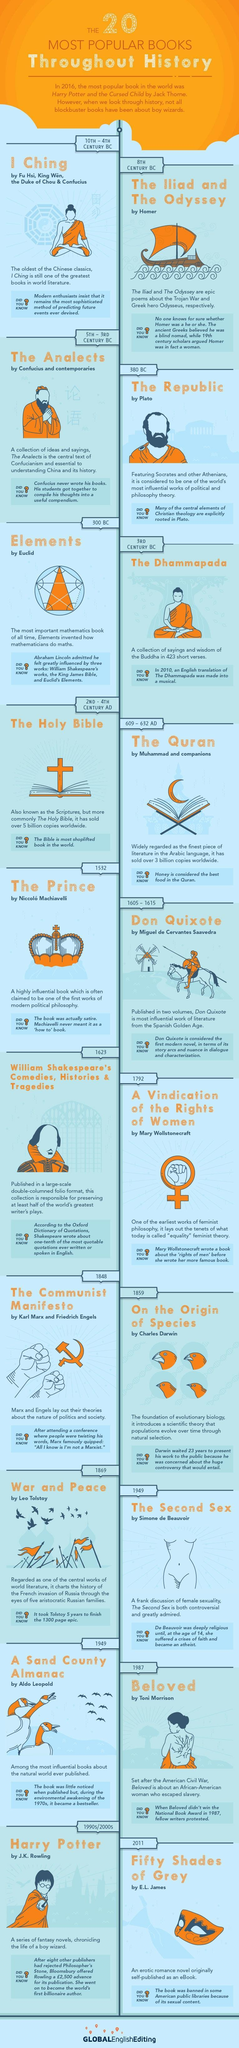Who wrote the book "On The Origin of Species"?
Answer the question with a short phrase. Charles Darwin In which year "The Communist Manifesto got released"? 1848 Who wrote the book "Beloved"? Toni Morrison In which period Holy Bible was written? 2ND - 4TH Century AD What is the other name of the Holy Bible? Scriptures Which was the famous book which got published in the 8th Century BC? The Iliad and the Odyssey In which year the book "War and Peace" got released? 1869 In which period "I Ching" got published? 8th Century BC What is the name of the work by Aldo Leopold? A sand County Almanac Which book is known as the best piece of Arabic literature? The Quran 